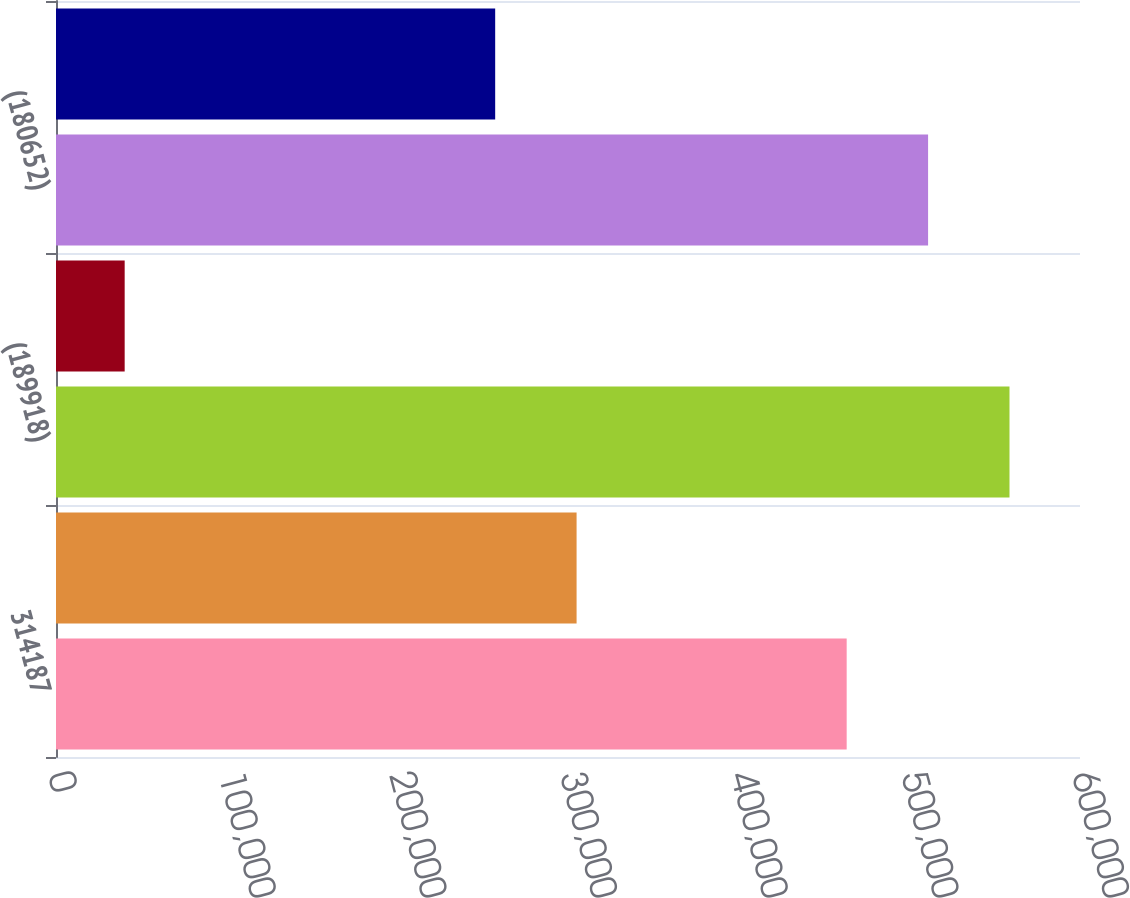<chart> <loc_0><loc_0><loc_500><loc_500><bar_chart><fcel>314187<fcel>50402<fcel>(189918)<fcel>9266<fcel>(180652)<fcel>183937<nl><fcel>463288<fcel>305032<fcel>558685<fcel>40238<fcel>510986<fcel>257333<nl></chart> 